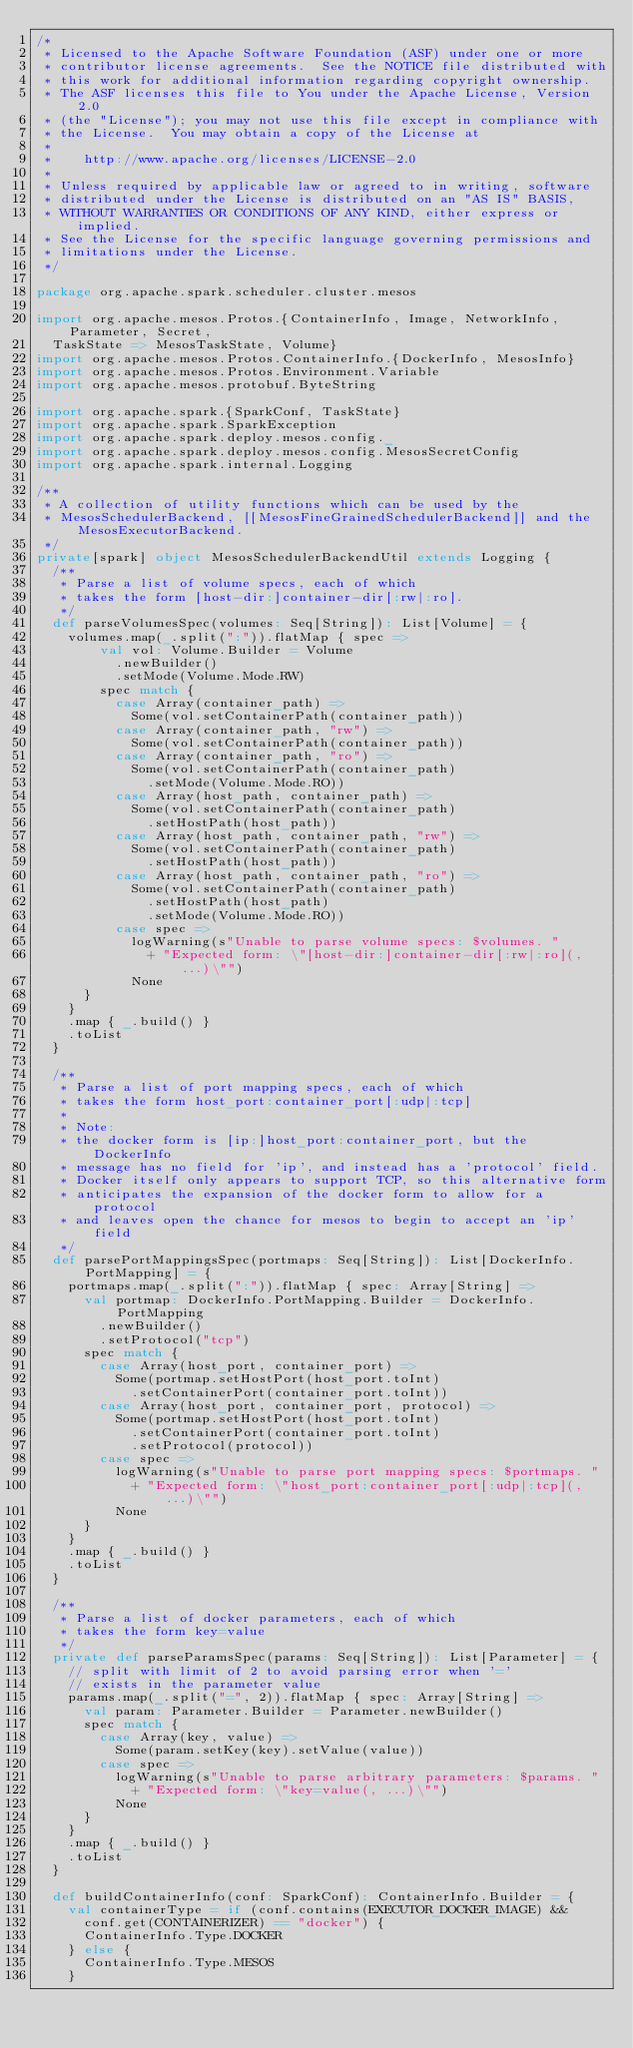Convert code to text. <code><loc_0><loc_0><loc_500><loc_500><_Scala_>/*
 * Licensed to the Apache Software Foundation (ASF) under one or more
 * contributor license agreements.  See the NOTICE file distributed with
 * this work for additional information regarding copyright ownership.
 * The ASF licenses this file to You under the Apache License, Version 2.0
 * (the "License"); you may not use this file except in compliance with
 * the License.  You may obtain a copy of the License at
 *
 *    http://www.apache.org/licenses/LICENSE-2.0
 *
 * Unless required by applicable law or agreed to in writing, software
 * distributed under the License is distributed on an "AS IS" BASIS,
 * WITHOUT WARRANTIES OR CONDITIONS OF ANY KIND, either express or implied.
 * See the License for the specific language governing permissions and
 * limitations under the License.
 */

package org.apache.spark.scheduler.cluster.mesos

import org.apache.mesos.Protos.{ContainerInfo, Image, NetworkInfo, Parameter, Secret,
  TaskState => MesosTaskState, Volume}
import org.apache.mesos.Protos.ContainerInfo.{DockerInfo, MesosInfo}
import org.apache.mesos.Protos.Environment.Variable
import org.apache.mesos.protobuf.ByteString

import org.apache.spark.{SparkConf, TaskState}
import org.apache.spark.SparkException
import org.apache.spark.deploy.mesos.config._
import org.apache.spark.deploy.mesos.config.MesosSecretConfig
import org.apache.spark.internal.Logging

/**
 * A collection of utility functions which can be used by the
 * MesosSchedulerBackend, [[MesosFineGrainedSchedulerBackend]] and the MesosExecutorBackend.
 */
private[spark] object MesosSchedulerBackendUtil extends Logging {
  /**
   * Parse a list of volume specs, each of which
   * takes the form [host-dir:]container-dir[:rw|:ro].
   */
  def parseVolumesSpec(volumes: Seq[String]): List[Volume] = {
    volumes.map(_.split(":")).flatMap { spec =>
        val vol: Volume.Builder = Volume
          .newBuilder()
          .setMode(Volume.Mode.RW)
        spec match {
          case Array(container_path) =>
            Some(vol.setContainerPath(container_path))
          case Array(container_path, "rw") =>
            Some(vol.setContainerPath(container_path))
          case Array(container_path, "ro") =>
            Some(vol.setContainerPath(container_path)
              .setMode(Volume.Mode.RO))
          case Array(host_path, container_path) =>
            Some(vol.setContainerPath(container_path)
              .setHostPath(host_path))
          case Array(host_path, container_path, "rw") =>
            Some(vol.setContainerPath(container_path)
              .setHostPath(host_path))
          case Array(host_path, container_path, "ro") =>
            Some(vol.setContainerPath(container_path)
              .setHostPath(host_path)
              .setMode(Volume.Mode.RO))
          case spec =>
            logWarning(s"Unable to parse volume specs: $volumes. "
              + "Expected form: \"[host-dir:]container-dir[:rw|:ro](, ...)\"")
            None
      }
    }
    .map { _.build() }
    .toList
  }

  /**
   * Parse a list of port mapping specs, each of which
   * takes the form host_port:container_port[:udp|:tcp]
   *
   * Note:
   * the docker form is [ip:]host_port:container_port, but the DockerInfo
   * message has no field for 'ip', and instead has a 'protocol' field.
   * Docker itself only appears to support TCP, so this alternative form
   * anticipates the expansion of the docker form to allow for a protocol
   * and leaves open the chance for mesos to begin to accept an 'ip' field
   */
  def parsePortMappingsSpec(portmaps: Seq[String]): List[DockerInfo.PortMapping] = {
    portmaps.map(_.split(":")).flatMap { spec: Array[String] =>
      val portmap: DockerInfo.PortMapping.Builder = DockerInfo.PortMapping
        .newBuilder()
        .setProtocol("tcp")
      spec match {
        case Array(host_port, container_port) =>
          Some(portmap.setHostPort(host_port.toInt)
            .setContainerPort(container_port.toInt))
        case Array(host_port, container_port, protocol) =>
          Some(portmap.setHostPort(host_port.toInt)
            .setContainerPort(container_port.toInt)
            .setProtocol(protocol))
        case spec =>
          logWarning(s"Unable to parse port mapping specs: $portmaps. "
            + "Expected form: \"host_port:container_port[:udp|:tcp](, ...)\"")
          None
      }
    }
    .map { _.build() }
    .toList
  }

  /**
   * Parse a list of docker parameters, each of which
   * takes the form key=value
   */
  private def parseParamsSpec(params: Seq[String]): List[Parameter] = {
    // split with limit of 2 to avoid parsing error when '='
    // exists in the parameter value
    params.map(_.split("=", 2)).flatMap { spec: Array[String] =>
      val param: Parameter.Builder = Parameter.newBuilder()
      spec match {
        case Array(key, value) =>
          Some(param.setKey(key).setValue(value))
        case spec =>
          logWarning(s"Unable to parse arbitrary parameters: $params. "
            + "Expected form: \"key=value(, ...)\"")
          None
      }
    }
    .map { _.build() }
    .toList
  }

  def buildContainerInfo(conf: SparkConf): ContainerInfo.Builder = {
    val containerType = if (conf.contains(EXECUTOR_DOCKER_IMAGE) &&
      conf.get(CONTAINERIZER) == "docker") {
      ContainerInfo.Type.DOCKER
    } else {
      ContainerInfo.Type.MESOS
    }
</code> 